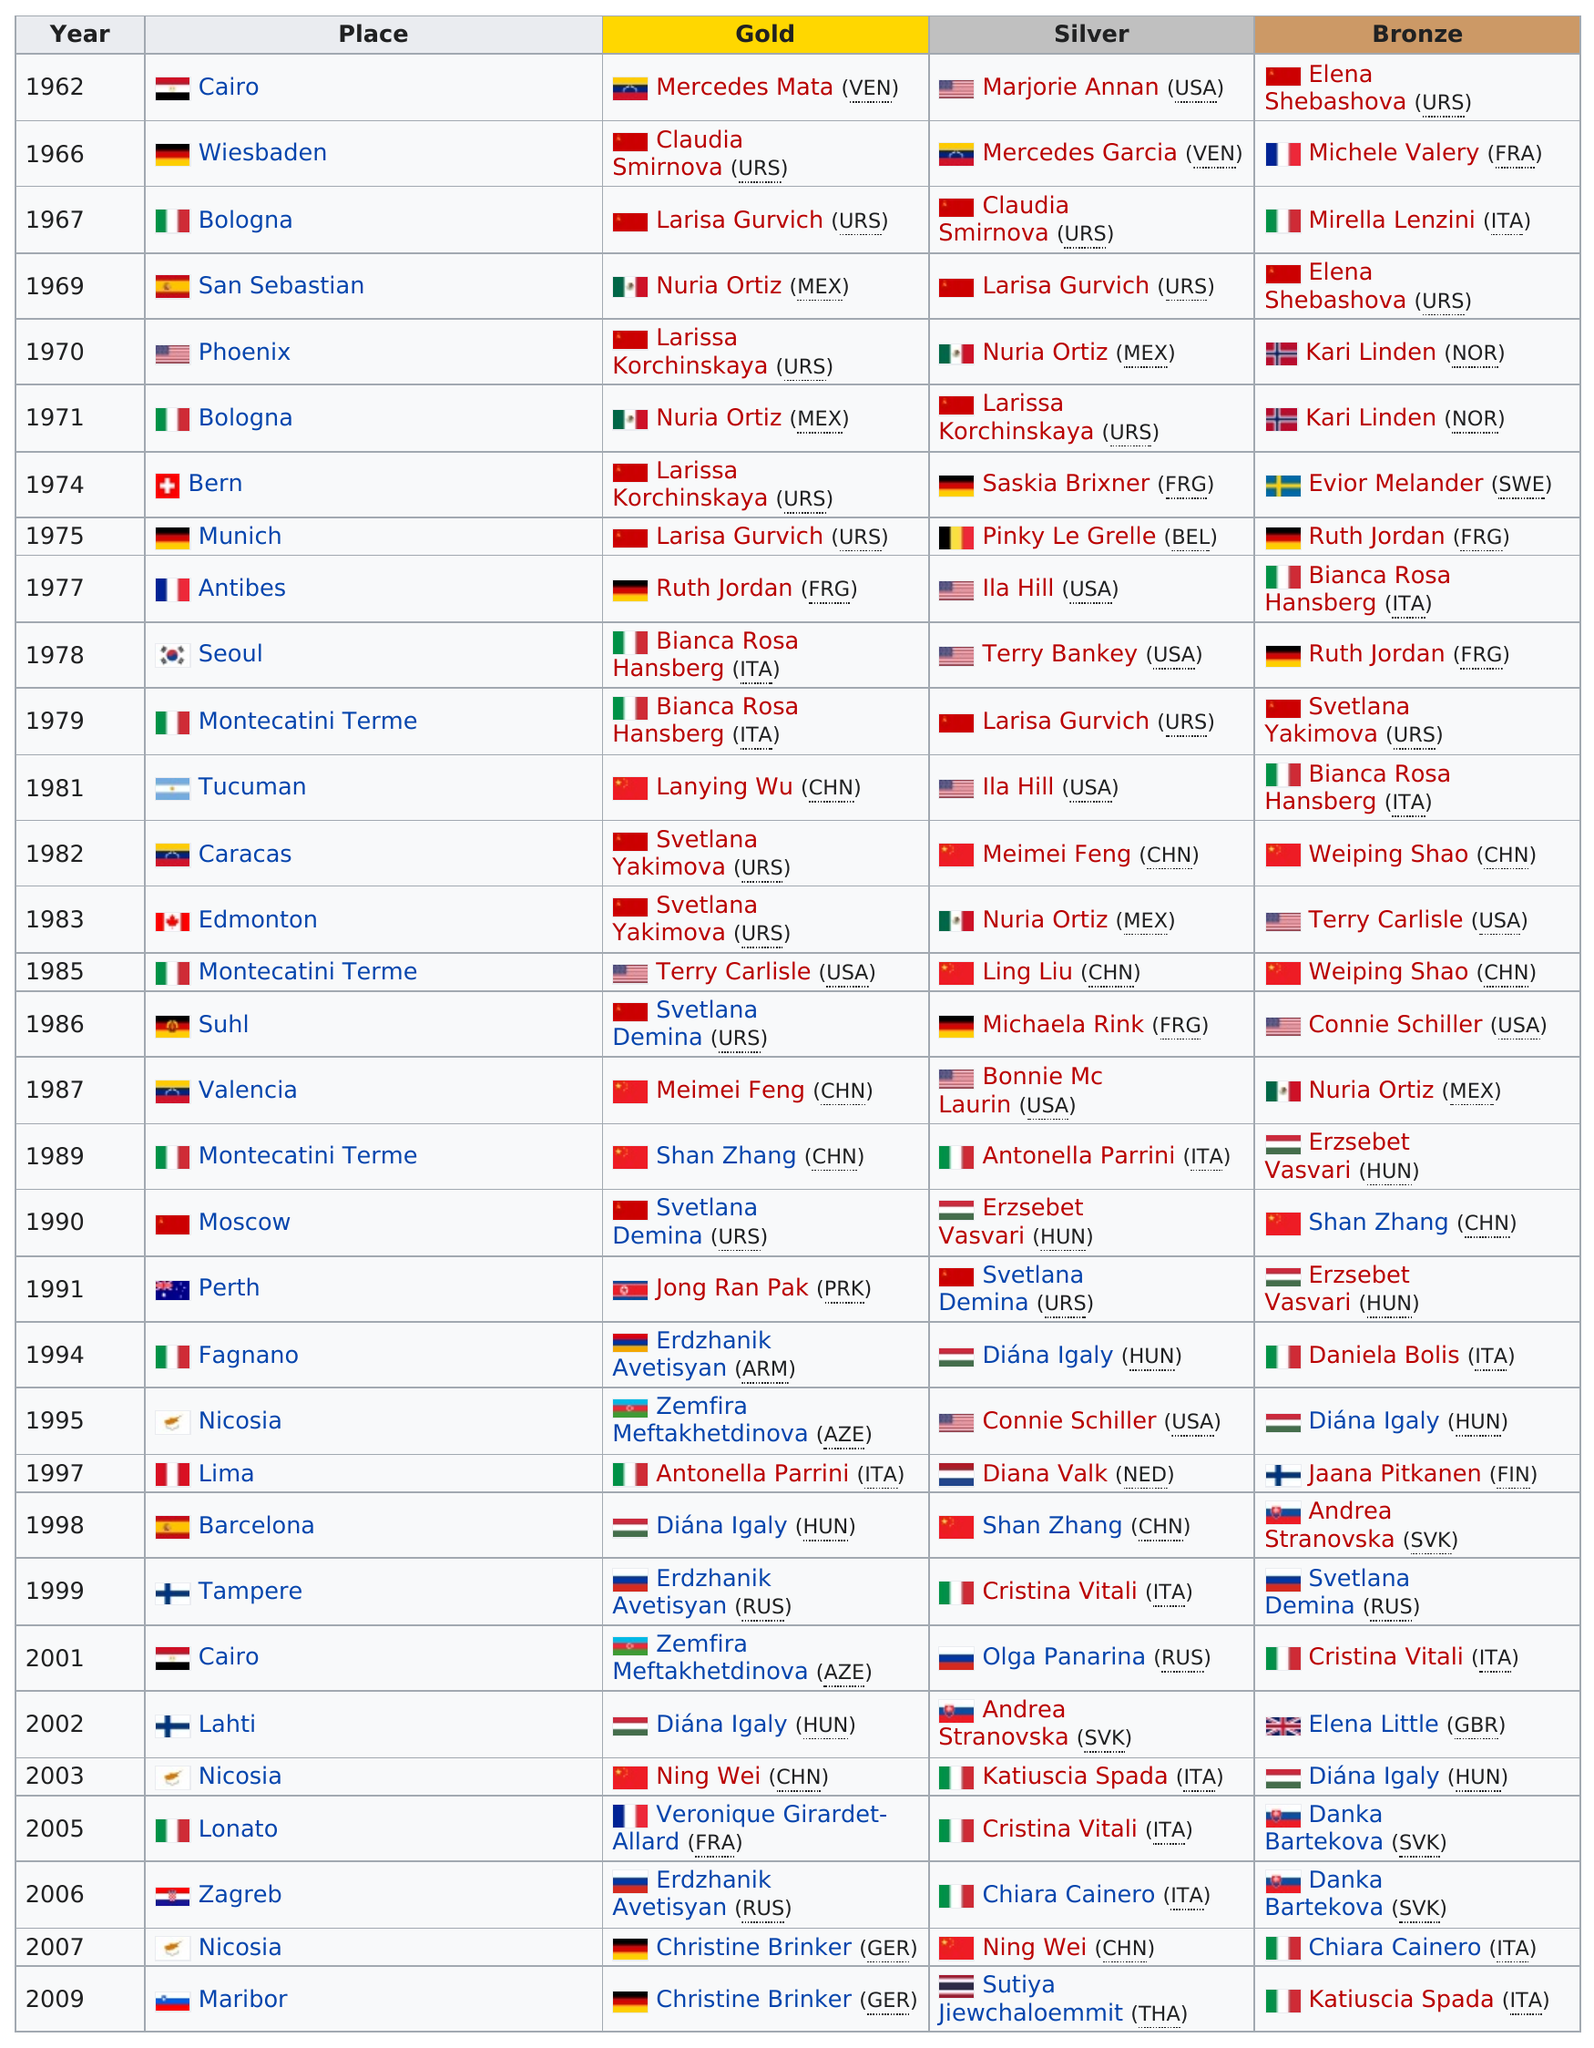Identify some key points in this picture. Nicosia is the place that is before the last. Mercedes Mata won the only gold medal in 1962. Marjorie Annan won second place after Mercedes, who had previously won first place. Munich is higher than Antibes if not, then who is? The total of silver for Cairo is 0. 